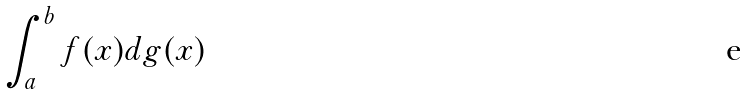<formula> <loc_0><loc_0><loc_500><loc_500>\int _ { a } ^ { b } f ( x ) d g ( x )</formula> 